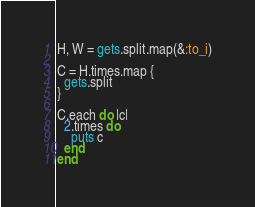Convert code to text. <code><loc_0><loc_0><loc_500><loc_500><_Ruby_>H, W = gets.split.map(&:to_i)

C = H.times.map {
  gets.split
}

C.each do |c|
  2.times do
    puts c
  end
end</code> 